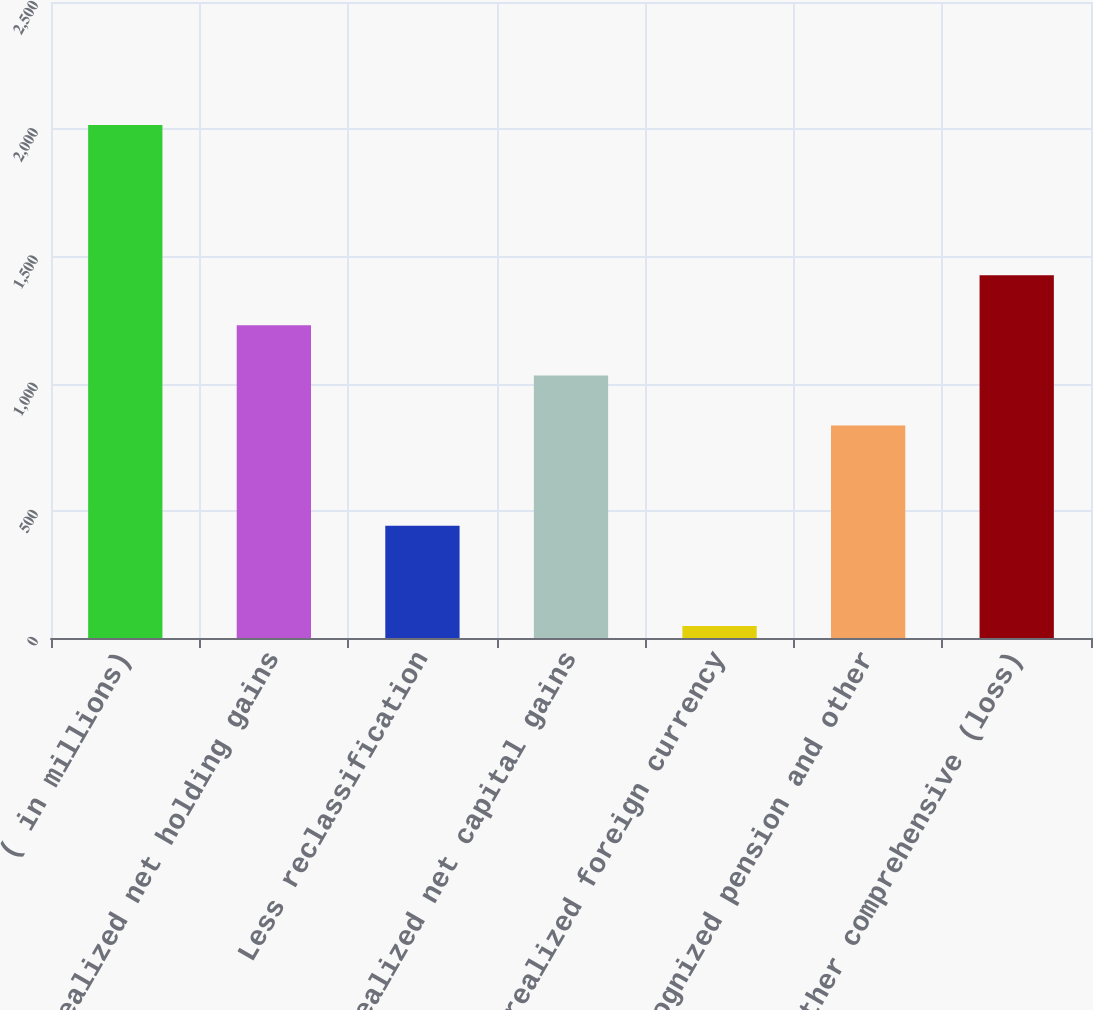<chart> <loc_0><loc_0><loc_500><loc_500><bar_chart><fcel>( in millions)<fcel>Unrealized net holding gains<fcel>Less reclassification<fcel>Unrealized net capital gains<fcel>Unrealized foreign currency<fcel>Unrecognized pension and other<fcel>Other comprehensive (loss)<nl><fcel>2017<fcel>1229<fcel>441<fcel>1032<fcel>47<fcel>835<fcel>1426<nl></chart> 